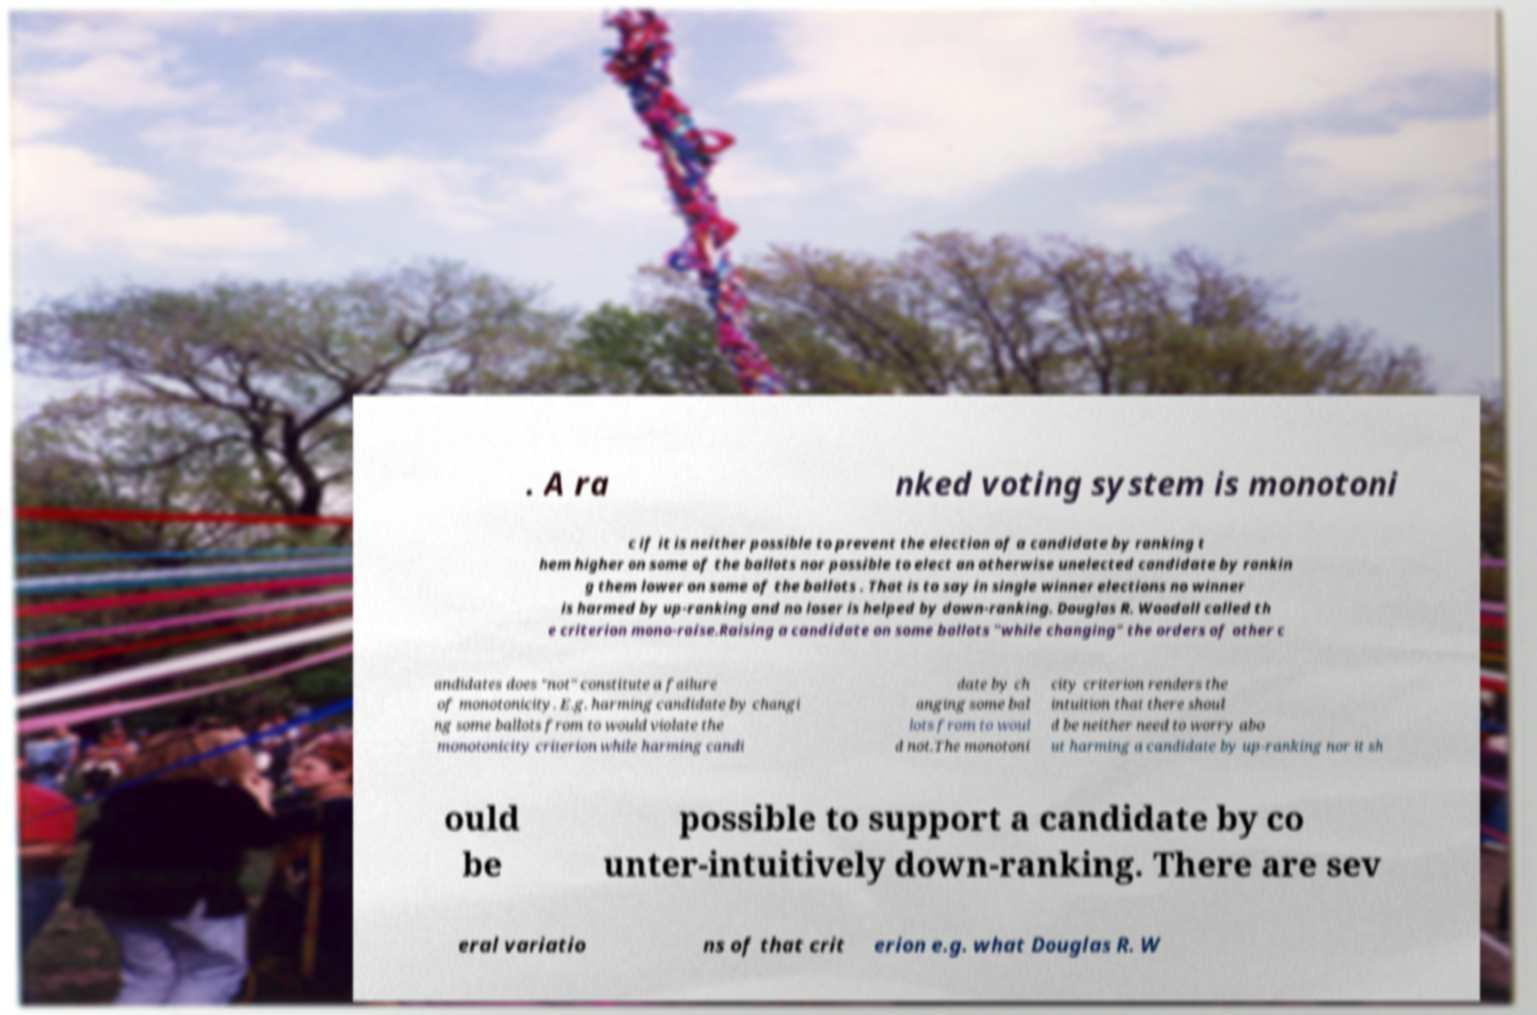Please identify and transcribe the text found in this image. . A ra nked voting system is monotoni c if it is neither possible to prevent the election of a candidate by ranking t hem higher on some of the ballots nor possible to elect an otherwise unelected candidate by rankin g them lower on some of the ballots . That is to say in single winner elections no winner is harmed by up-ranking and no loser is helped by down-ranking. Douglas R. Woodall called th e criterion mono-raise.Raising a candidate on some ballots "while changing" the orders of other c andidates does "not" constitute a failure of monotonicity. E.g. harming candidate by changi ng some ballots from to would violate the monotonicity criterion while harming candi date by ch anging some bal lots from to woul d not.The monotoni city criterion renders the intuition that there shoul d be neither need to worry abo ut harming a candidate by up-ranking nor it sh ould be possible to support a candidate by co unter-intuitively down-ranking. There are sev eral variatio ns of that crit erion e.g. what Douglas R. W 